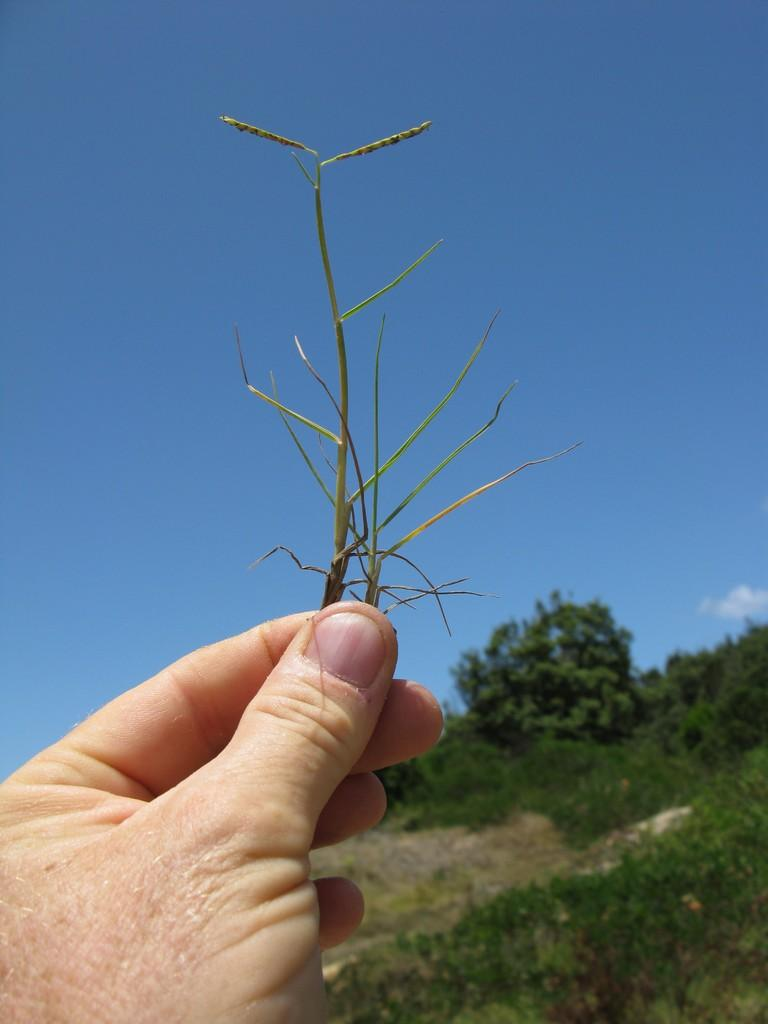Who or what is present in the image? There is a person in the image. What is the person holding in the image? The person's hand is holding a plant. What can be seen in the background of the image? There are plants and trees in the background of the image. What else is visible in the background of the image? The sky is visible in the background of the image. How many girls are crossing the bridge in the image? There is no bridge or girls present in the image. What type of beast can be seen interacting with the person in the image? There is no beast present in the image; the person is holding a plant. 